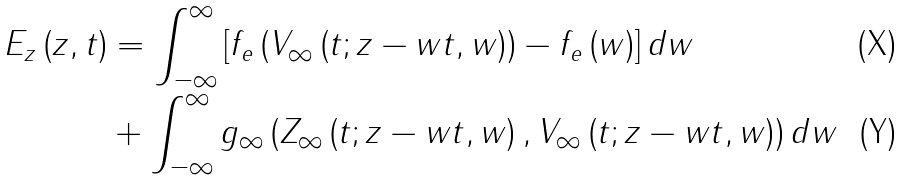<formula> <loc_0><loc_0><loc_500><loc_500>E _ { z } \left ( z , t \right ) & = \int _ { - \infty } ^ { \infty } \left [ f _ { e } \left ( V _ { \infty } \left ( t ; z - w t , w \right ) \right ) - f _ { e } \left ( w \right ) \right ] d w \\ & + \int _ { - \infty } ^ { \infty } g _ { \infty } \left ( Z _ { \infty } \left ( t ; z - w t , w \right ) , V _ { \infty } \left ( t ; z - w t , w \right ) \right ) d w</formula> 